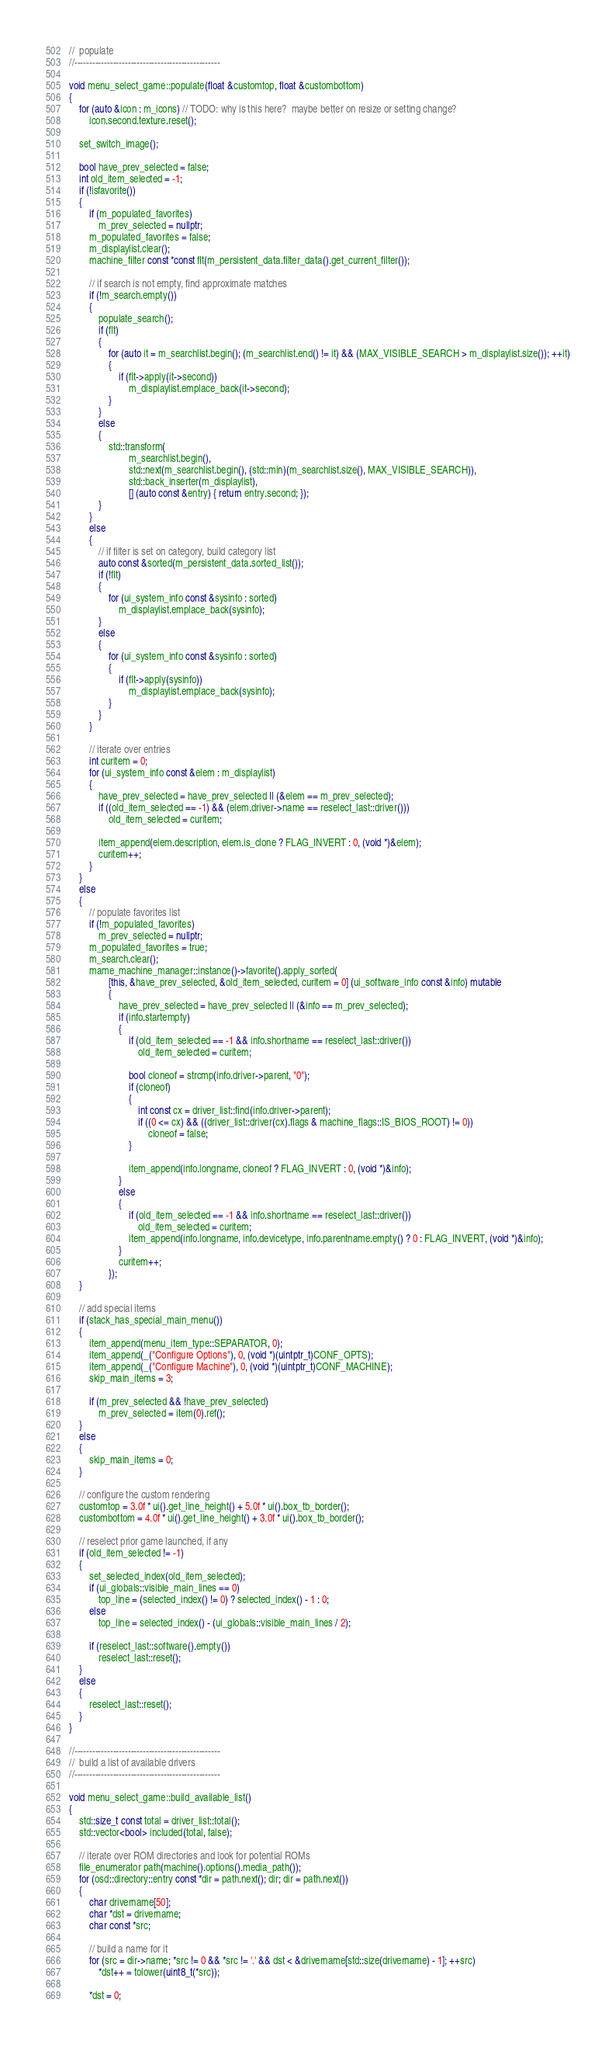Convert code to text. <code><loc_0><loc_0><loc_500><loc_500><_C++_>//  populate
//-------------------------------------------------

void menu_select_game::populate(float &customtop, float &custombottom)
{
	for (auto &icon : m_icons) // TODO: why is this here?  maybe better on resize or setting change?
		icon.second.texture.reset();

	set_switch_image();

	bool have_prev_selected = false;
	int old_item_selected = -1;
	if (!isfavorite())
	{
		if (m_populated_favorites)
			m_prev_selected = nullptr;
		m_populated_favorites = false;
		m_displaylist.clear();
		machine_filter const *const flt(m_persistent_data.filter_data().get_current_filter());

		// if search is not empty, find approximate matches
		if (!m_search.empty())
		{
			populate_search();
			if (flt)
			{
				for (auto it = m_searchlist.begin(); (m_searchlist.end() != it) && (MAX_VISIBLE_SEARCH > m_displaylist.size()); ++it)
				{
					if (flt->apply(it->second))
						m_displaylist.emplace_back(it->second);
				}
			}
			else
			{
				std::transform(
						m_searchlist.begin(),
						std::next(m_searchlist.begin(), (std::min)(m_searchlist.size(), MAX_VISIBLE_SEARCH)),
						std::back_inserter(m_displaylist),
						[] (auto const &entry) { return entry.second; });
			}
		}
		else
		{
			// if filter is set on category, build category list
			auto const &sorted(m_persistent_data.sorted_list());
			if (!flt)
			{
				for (ui_system_info const &sysinfo : sorted)
					m_displaylist.emplace_back(sysinfo);
			}
			else
			{
				for (ui_system_info const &sysinfo : sorted)
				{
					if (flt->apply(sysinfo))
						m_displaylist.emplace_back(sysinfo);
				}
			}
		}

		// iterate over entries
		int curitem = 0;
		for (ui_system_info const &elem : m_displaylist)
		{
			have_prev_selected = have_prev_selected || (&elem == m_prev_selected);
			if ((old_item_selected == -1) && (elem.driver->name == reselect_last::driver()))
				old_item_selected = curitem;

			item_append(elem.description, elem.is_clone ? FLAG_INVERT : 0, (void *)&elem);
			curitem++;
		}
	}
	else
	{
		// populate favorites list
		if (!m_populated_favorites)
			m_prev_selected = nullptr;
		m_populated_favorites = true;
		m_search.clear();
		mame_machine_manager::instance()->favorite().apply_sorted(
				[this, &have_prev_selected, &old_item_selected, curitem = 0] (ui_software_info const &info) mutable
				{
					have_prev_selected = have_prev_selected || (&info == m_prev_selected);
					if (info.startempty)
					{
						if (old_item_selected == -1 && info.shortname == reselect_last::driver())
							old_item_selected = curitem;

						bool cloneof = strcmp(info.driver->parent, "0");
						if (cloneof)
						{
							int const cx = driver_list::find(info.driver->parent);
							if ((0 <= cx) && ((driver_list::driver(cx).flags & machine_flags::IS_BIOS_ROOT) != 0))
								cloneof = false;
						}

						item_append(info.longname, cloneof ? FLAG_INVERT : 0, (void *)&info);
					}
					else
					{
						if (old_item_selected == -1 && info.shortname == reselect_last::driver())
							old_item_selected = curitem;
						item_append(info.longname, info.devicetype, info.parentname.empty() ? 0 : FLAG_INVERT, (void *)&info);
					}
					curitem++;
				});
	}

	// add special items
	if (stack_has_special_main_menu())
	{
		item_append(menu_item_type::SEPARATOR, 0);
		item_append(_("Configure Options"), 0, (void *)(uintptr_t)CONF_OPTS);
		item_append(_("Configure Machine"), 0, (void *)(uintptr_t)CONF_MACHINE);
		skip_main_items = 3;

		if (m_prev_selected && !have_prev_selected)
			m_prev_selected = item(0).ref();
	}
	else
	{
		skip_main_items = 0;
	}

	// configure the custom rendering
	customtop = 3.0f * ui().get_line_height() + 5.0f * ui().box_tb_border();
	custombottom = 4.0f * ui().get_line_height() + 3.0f * ui().box_tb_border();

	// reselect prior game launched, if any
	if (old_item_selected != -1)
	{
		set_selected_index(old_item_selected);
		if (ui_globals::visible_main_lines == 0)
			top_line = (selected_index() != 0) ? selected_index() - 1 : 0;
		else
			top_line = selected_index() - (ui_globals::visible_main_lines / 2);

		if (reselect_last::software().empty())
			reselect_last::reset();
	}
	else
	{
		reselect_last::reset();
	}
}

//-------------------------------------------------
//  build a list of available drivers
//-------------------------------------------------

void menu_select_game::build_available_list()
{
	std::size_t const total = driver_list::total();
	std::vector<bool> included(total, false);

	// iterate over ROM directories and look for potential ROMs
	file_enumerator path(machine().options().media_path());
	for (osd::directory::entry const *dir = path.next(); dir; dir = path.next())
	{
		char drivername[50];
		char *dst = drivername;
		char const *src;

		// build a name for it
		for (src = dir->name; *src != 0 && *src != '.' && dst < &drivername[std::size(drivername) - 1]; ++src)
			*dst++ = tolower(uint8_t(*src));

		*dst = 0;</code> 